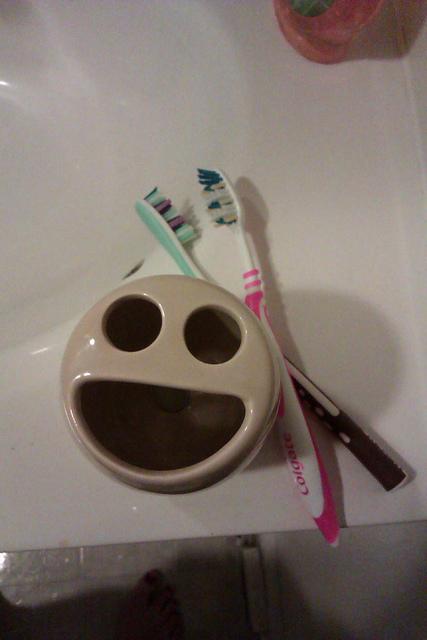Is this a toothbrush holder?
Write a very short answer. Yes. How is the brushes placed?
Keep it brief. Criss cross. What are the eyes made of?
Short answer required. Holes. Where are the toothbrushes?
Quick response, please. Counter. Is this a happy face?
Be succinct. Yes. How many toothbrushes are in the picture?
Answer briefly. 2. 